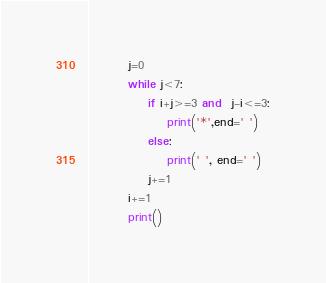Convert code to text. <code><loc_0><loc_0><loc_500><loc_500><_Python_>        j=0
        while j<7:
            if i+j>=3 and  j-i<=3:
                print('*',end=' ')
            else:
                print(' ', end=' ')
            j+=1
        i+=1
        print()</code> 